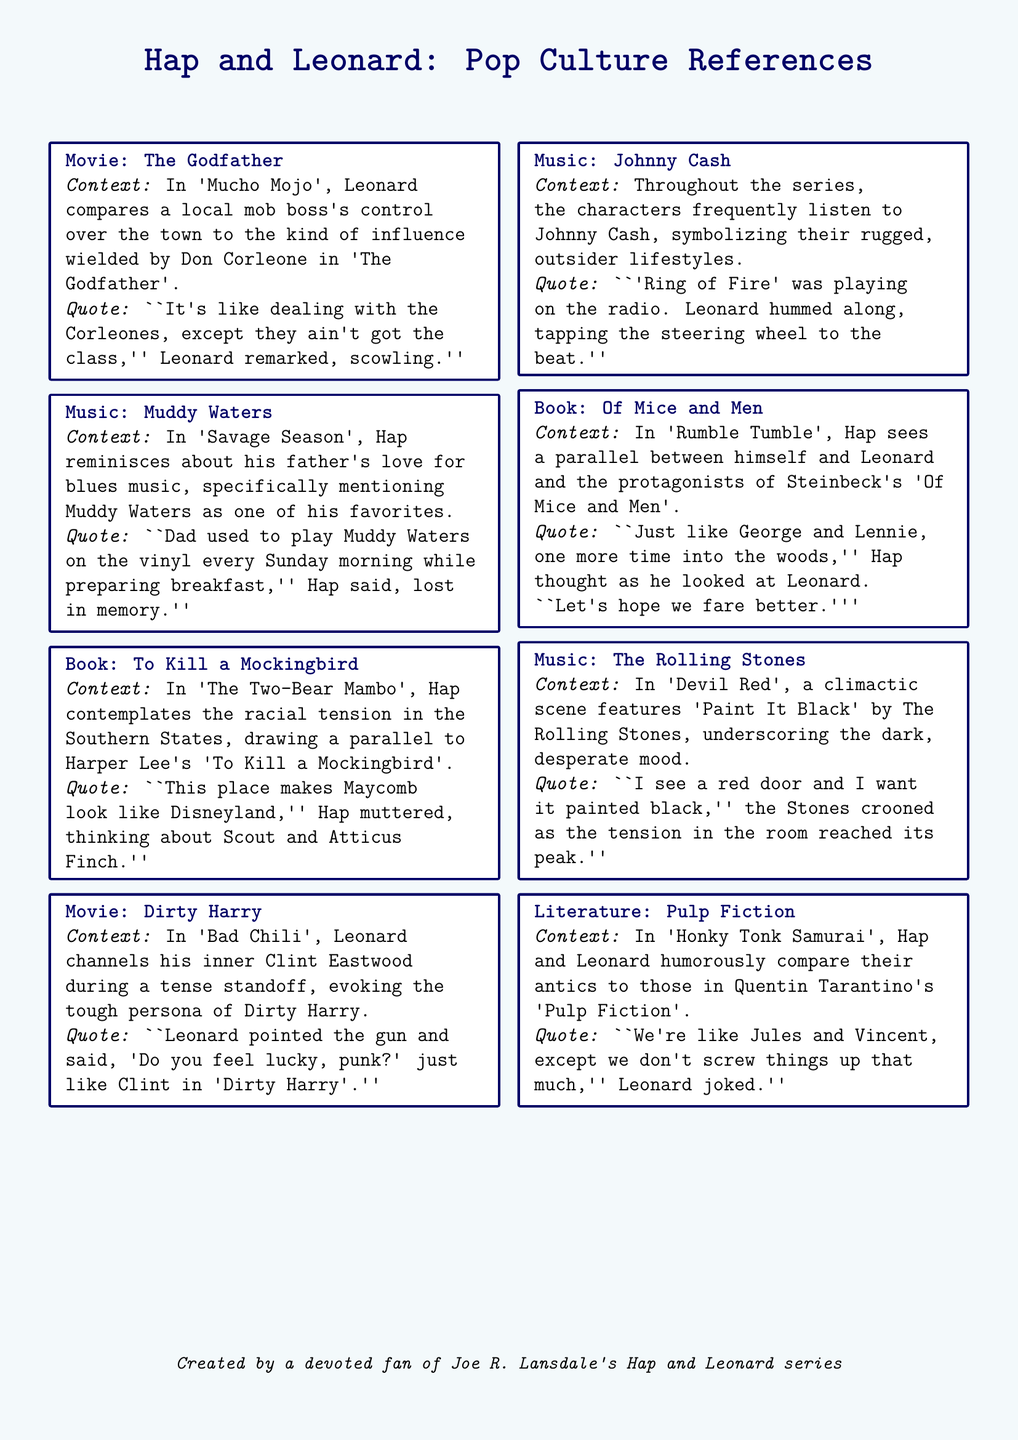What movie is referenced in 'Mucho Mojo'? The movie referenced is 'The Godfather', which is mentioned in the context of comparing a local mob boss's influence.
Answer: The Godfather Which music artist does Hap reminisce about in 'Savage Season'? Hap recalls Muddy Waters as a favorite of his father's during a nostalgic moment about blues music.
Answer: Muddy Waters What book is compared to the racial tension in 'The Two-Bear Mambo'? Hap draws a parallel between the environment he is in and 'To Kill a Mockingbird' by Harper Lee.
Answer: To Kill a Mockingbird In which chapter does Leonard channel Clint Eastwood's character? Leonard channels Clint Eastwood during a tense standoff in 'Bad Chili', referencing the persona of Dirty Harry.
Answer: Bad Chili What song is playing during a climactic scene in 'Devil Red'? The song featured during the intense scene is 'Paint It Black' by The Rolling Stones.
Answer: Paint It Black Who do Hap and Leonard compare themselves to in 'Honky Tonk Samurai'? They humorously compare themselves to Jules and Vincent from 'Pulp Fiction' in their antics.
Answer: Jules and Vincent Which literature classic is mentioned in 'Rumble Tumble'? 'Of Mice and Men' by John Steinbeck is referenced as Hap sees a parallel between himself and Leonard.
Answer: Of Mice and Men What is the primary genre of music mentioned throughout the series? The music genre frequently mentioned is blues, particularly through references to artists like Johnny Cash and Muddy Waters.
Answer: Blues Which character quotes a famous line from 'Dirty Harry' in 'Bad Chili'? Leonard quotes the famous line during a tense moment, channeling Clint Eastwood's persona.
Answer: Leonard 